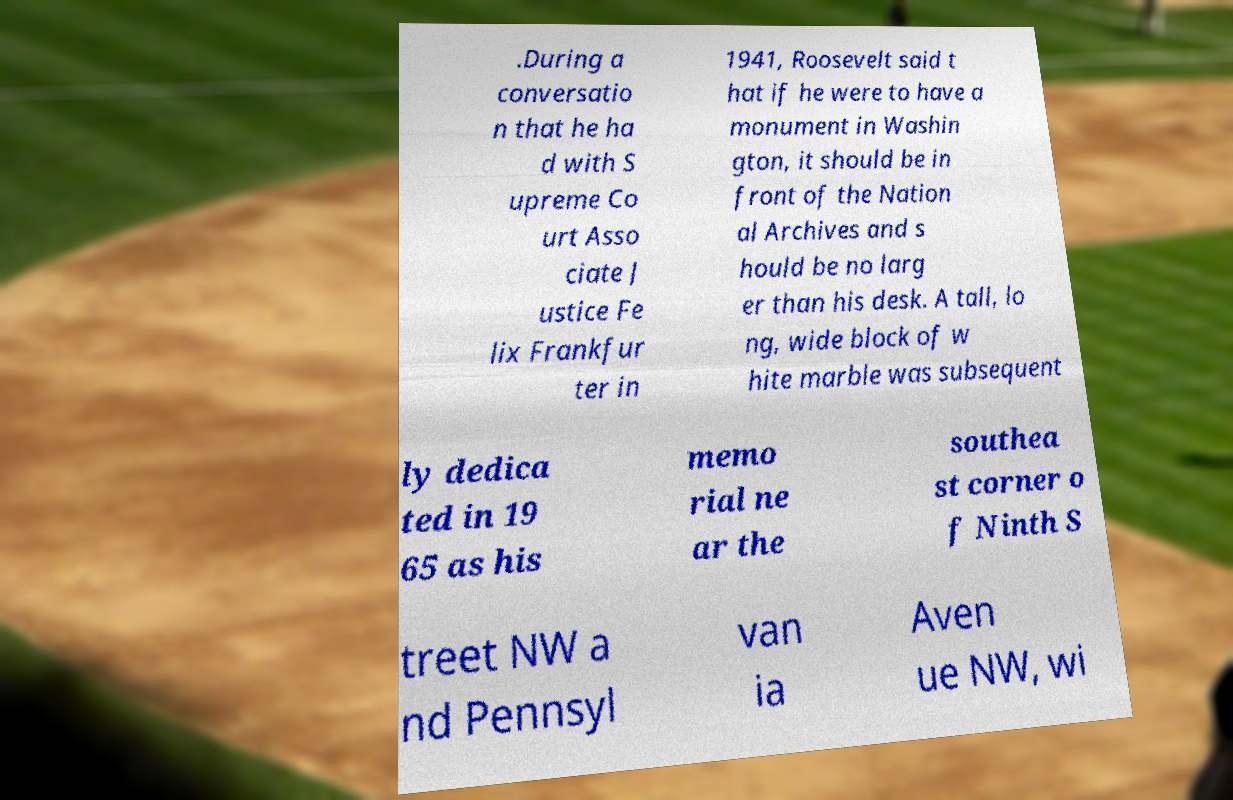What messages or text are displayed in this image? I need them in a readable, typed format. .During a conversatio n that he ha d with S upreme Co urt Asso ciate J ustice Fe lix Frankfur ter in 1941, Roosevelt said t hat if he were to have a monument in Washin gton, it should be in front of the Nation al Archives and s hould be no larg er than his desk. A tall, lo ng, wide block of w hite marble was subsequent ly dedica ted in 19 65 as his memo rial ne ar the southea st corner o f Ninth S treet NW a nd Pennsyl van ia Aven ue NW, wi 